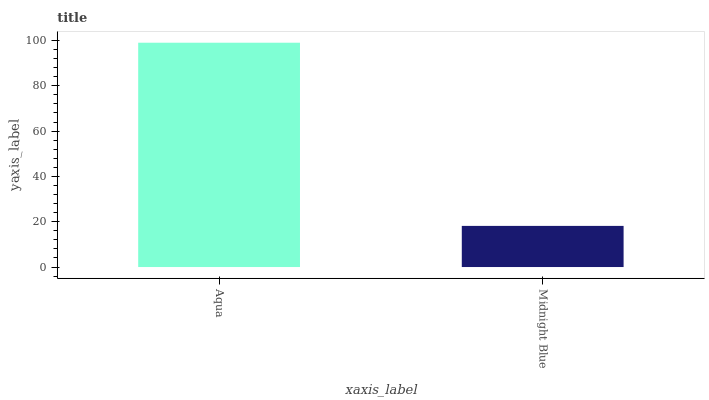Is Midnight Blue the minimum?
Answer yes or no. Yes. Is Aqua the maximum?
Answer yes or no. Yes. Is Midnight Blue the maximum?
Answer yes or no. No. Is Aqua greater than Midnight Blue?
Answer yes or no. Yes. Is Midnight Blue less than Aqua?
Answer yes or no. Yes. Is Midnight Blue greater than Aqua?
Answer yes or no. No. Is Aqua less than Midnight Blue?
Answer yes or no. No. Is Aqua the high median?
Answer yes or no. Yes. Is Midnight Blue the low median?
Answer yes or no. Yes. Is Midnight Blue the high median?
Answer yes or no. No. Is Aqua the low median?
Answer yes or no. No. 